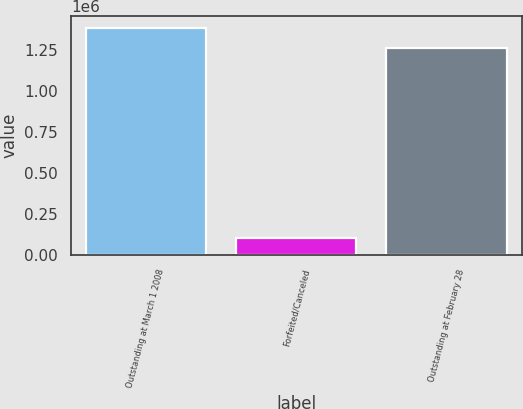Convert chart to OTSL. <chart><loc_0><loc_0><loc_500><loc_500><bar_chart><fcel>Outstanding at March 1 2008<fcel>Forfeited/Canceled<fcel>Outstanding at February 28<nl><fcel>1.386e+06<fcel>101000<fcel>1.26e+06<nl></chart> 